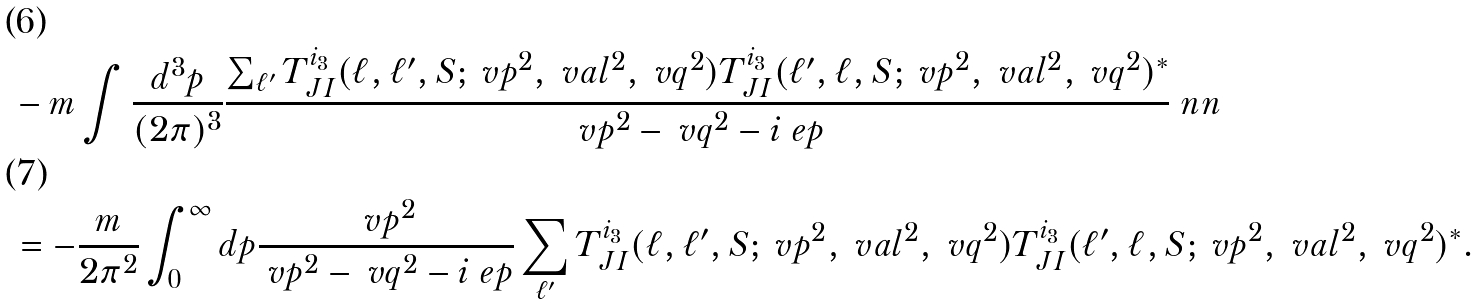<formula> <loc_0><loc_0><loc_500><loc_500>& - m \int \frac { d ^ { 3 } p } { ( 2 \pi ) ^ { 3 } } \frac { \sum _ { \ell ^ { \prime } } T _ { J I } ^ { i _ { 3 } } ( \ell , \ell ^ { \prime } , S ; \ v p ^ { 2 } , \ v a l ^ { 2 } , \ v q ^ { 2 } ) T _ { J I } ^ { i _ { 3 } } ( \ell ^ { \prime } , \ell , S ; \ v p ^ { 2 } , \ v a l ^ { 2 } , \ v q ^ { 2 } ) ^ { * } } { \ v p ^ { 2 } - \ v q ^ { 2 } - i \ e p } \ n n \\ & = - \frac { m } { 2 \pi ^ { 2 } } \int _ { 0 } ^ { \infty } d p \frac { \ v p ^ { 2 } } { \ v p ^ { 2 } - \ v q ^ { 2 } - i \ e p } \sum _ { \ell ^ { \prime } } T _ { J I } ^ { i _ { 3 } } ( \ell , \ell ^ { \prime } , S ; \ v p ^ { 2 } , \ v a l ^ { 2 } , \ v q ^ { 2 } ) T _ { J I } ^ { i _ { 3 } } ( \ell ^ { \prime } , \ell , S ; \ v p ^ { 2 } , \ v a l ^ { 2 } , \ v q ^ { 2 } ) ^ { * } .</formula> 